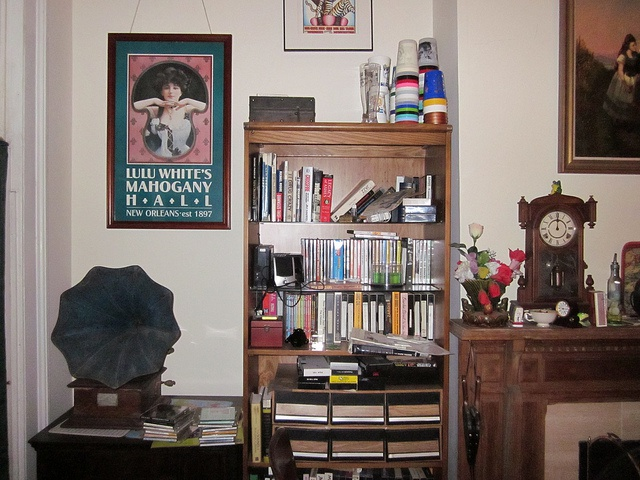Describe the objects in this image and their specific colors. I can see book in darkgray, black, gray, and lightgray tones, book in darkgray, lightgray, gray, and black tones, vase in darkgray, black, maroon, and brown tones, clock in darkgray, tan, and gray tones, and cup in darkgray, lightgray, and gray tones in this image. 